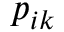Convert formula to latex. <formula><loc_0><loc_0><loc_500><loc_500>p _ { i k }</formula> 